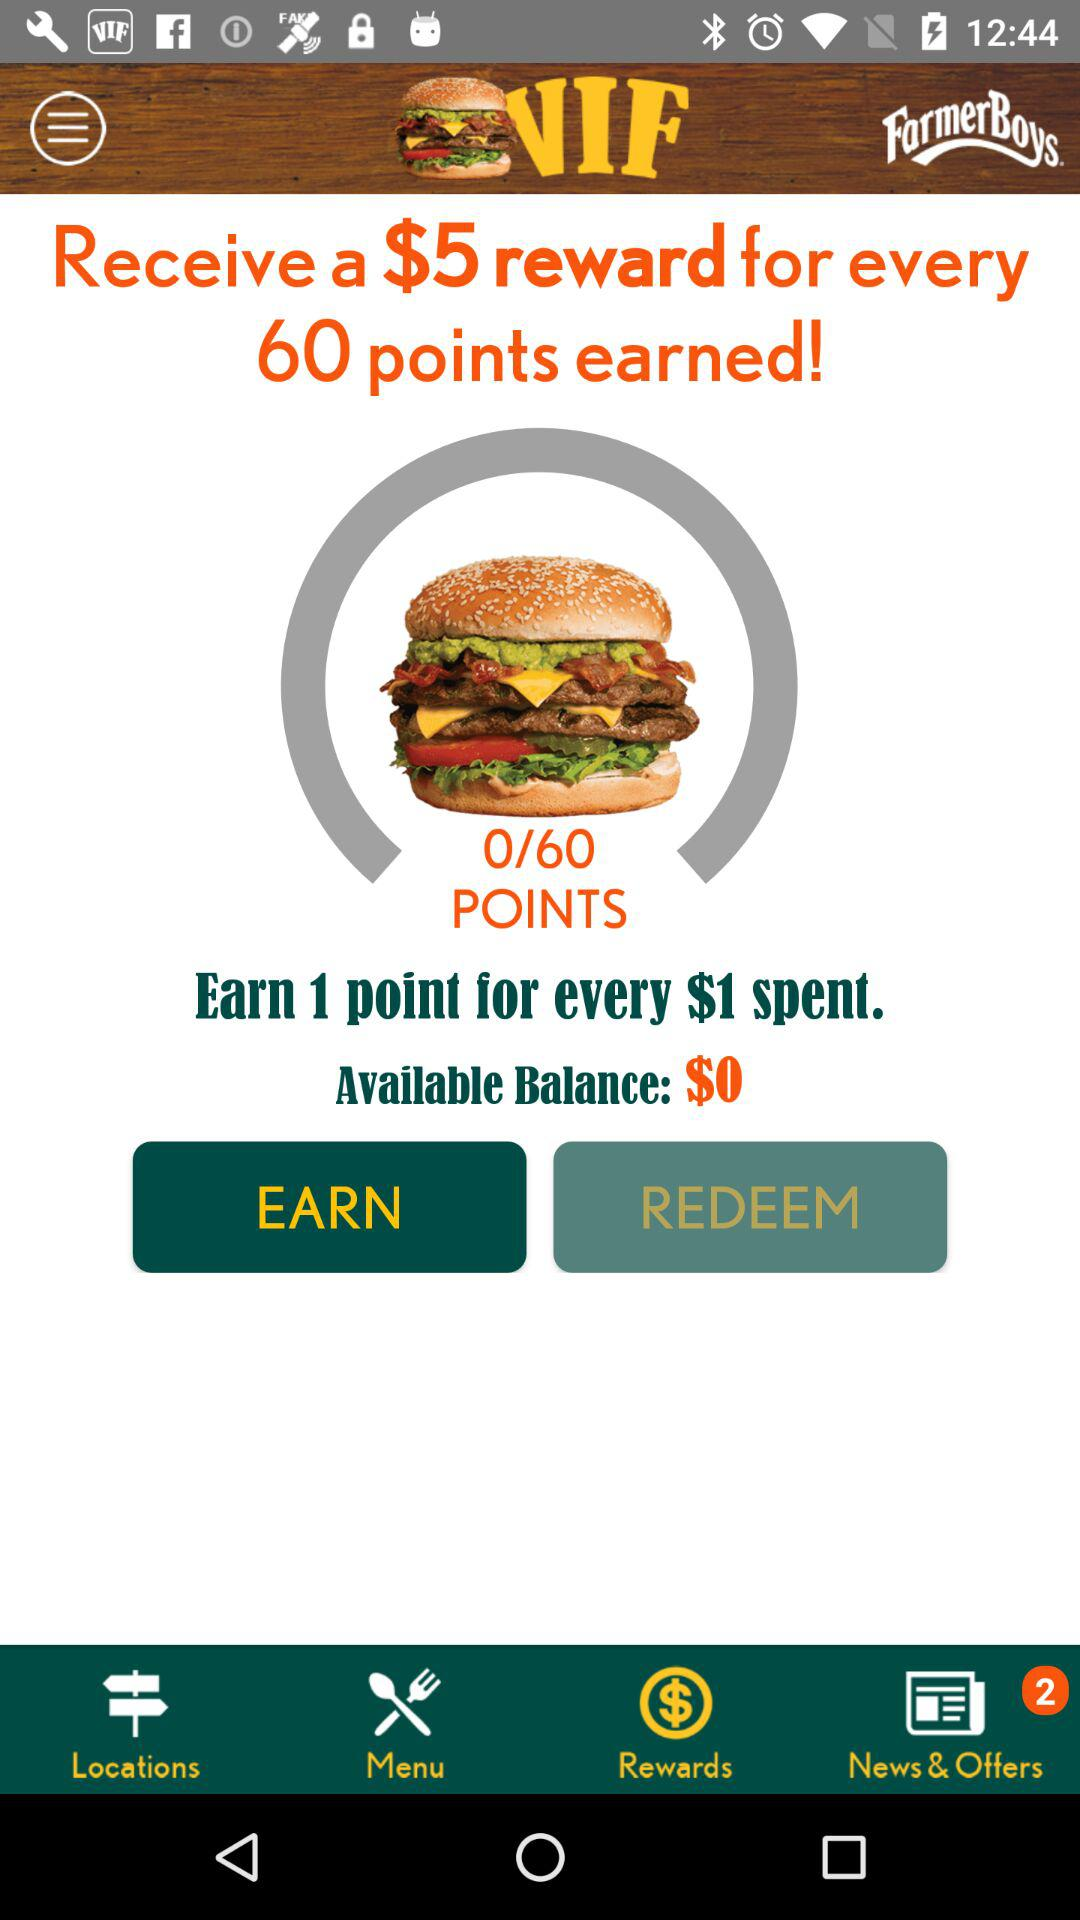How many points did I get out of 60? You got 0 points out of 60. 